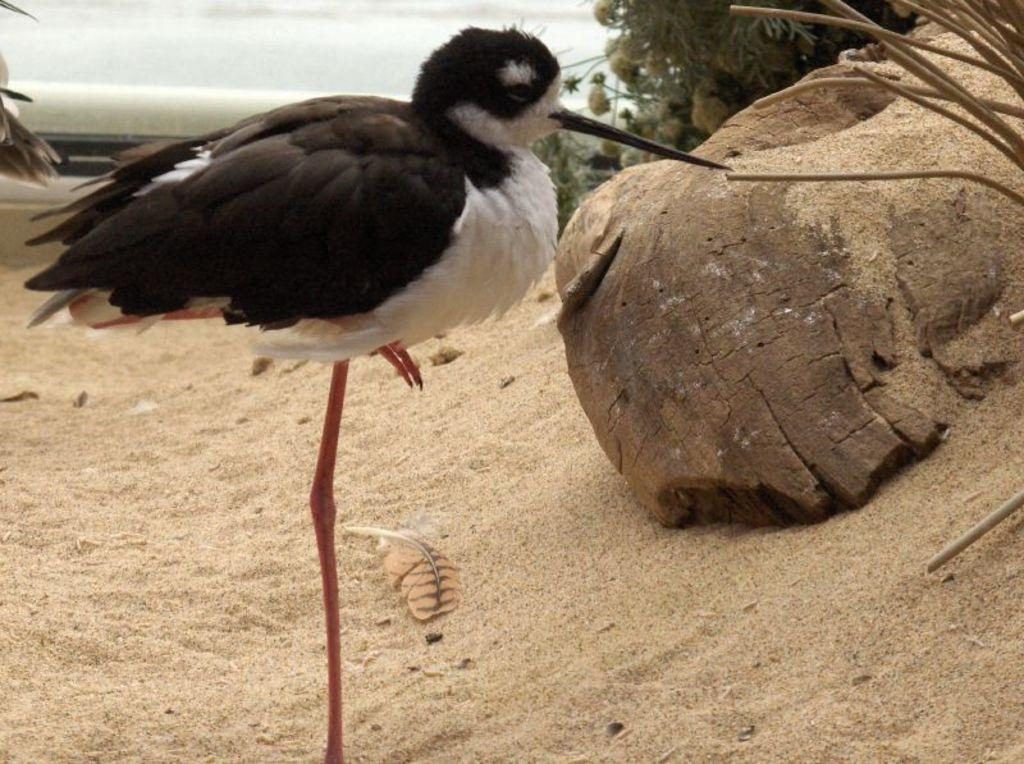What type of animal is in the picture? There is a bird in the picture. Can you describe the bird's position in the image? The bird is standing in front. What colors can be seen on the bird? The bird is white and black in color. What can be seen in the background of the image? There is sand and plants visible in the background. What type of silk fabric is draped over the bird in the image? There is no silk fabric present in the image; the bird is standing in front and is not covered by any fabric. 